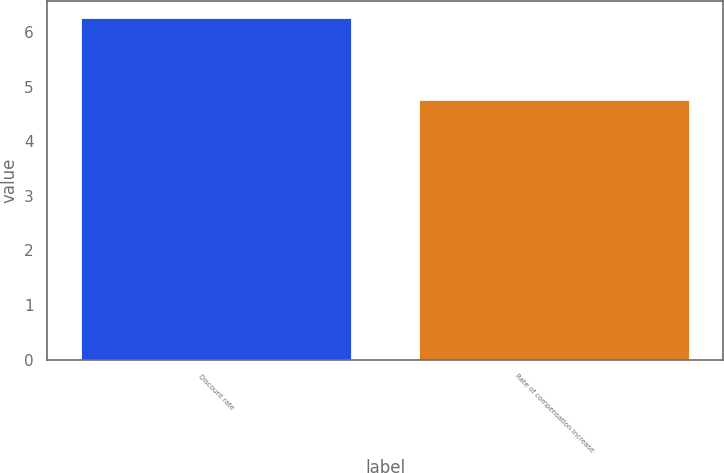Convert chart to OTSL. <chart><loc_0><loc_0><loc_500><loc_500><bar_chart><fcel>Discount rate<fcel>Rate of compensation increase<nl><fcel>6.26<fcel>4.75<nl></chart> 